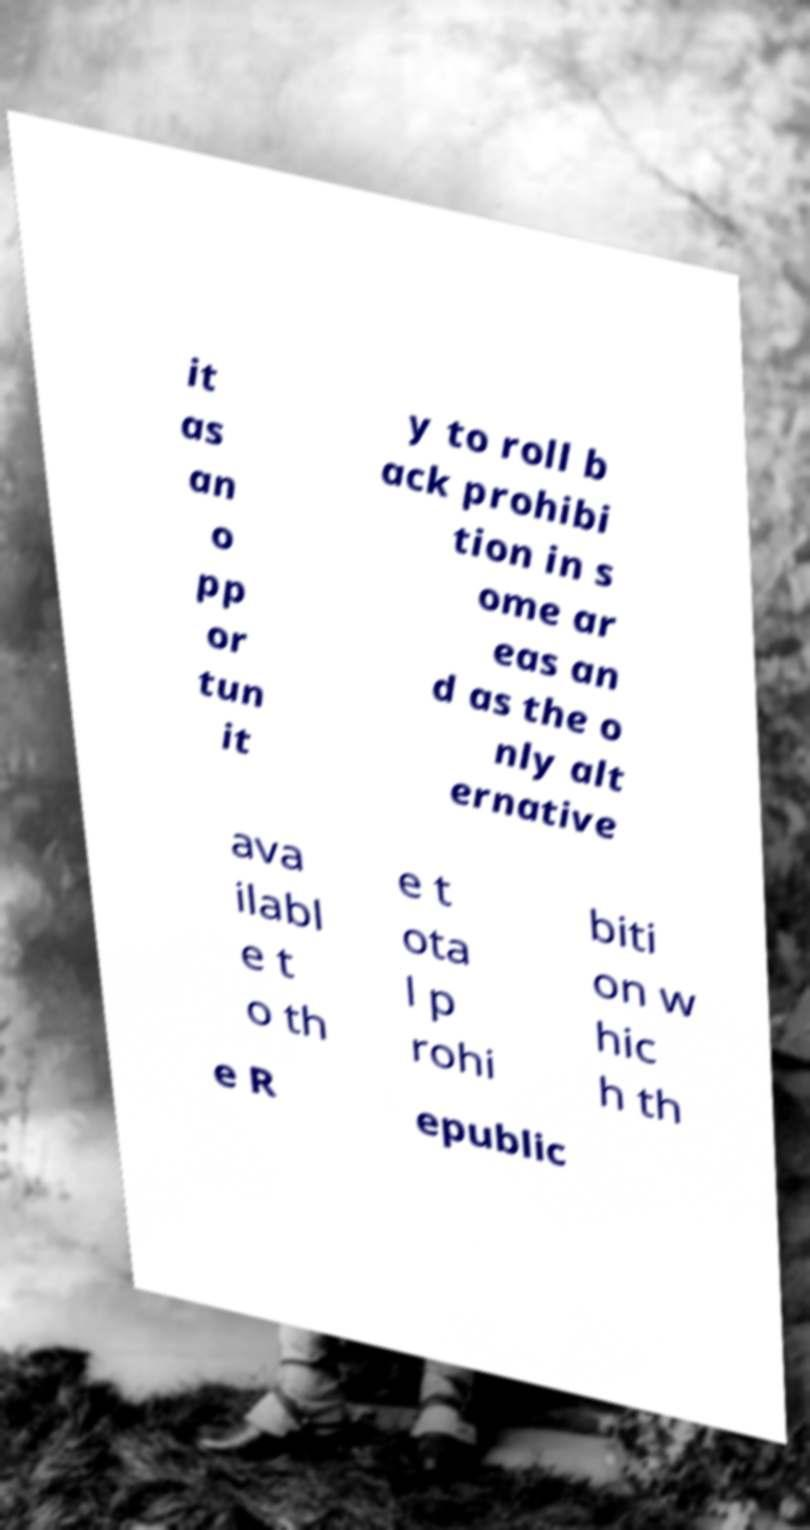What messages or text are displayed in this image? I need them in a readable, typed format. it as an o pp or tun it y to roll b ack prohibi tion in s ome ar eas an d as the o nly alt ernative ava ilabl e t o th e t ota l p rohi biti on w hic h th e R epublic 